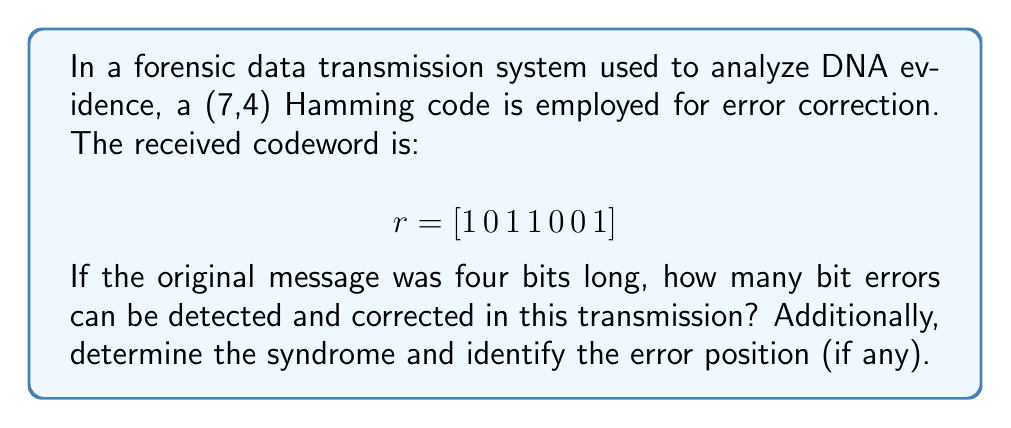Give your solution to this math problem. 1) The (7,4) Hamming code can detect up to 2 errors and correct 1 error.

2) To find the syndrome and error position:
   
   The parity-check matrix H for (7,4) Hamming code is:
   
   $$H = \begin{bmatrix}
   1 & 1 & 1 & 0 & 1 & 0 & 0 \\
   1 & 1 & 0 & 1 & 0 & 1 & 0 \\
   1 & 0 & 1 & 1 & 0 & 0 & 1
   \end{bmatrix}$$

3) Calculate the syndrome $s = Hr^T$:
   
   $$s = \begin{bmatrix}
   1 & 1 & 1 & 0 & 1 & 0 & 0 \\
   1 & 1 & 0 & 1 & 0 & 1 & 0 \\
   1 & 0 & 1 & 1 & 0 & 0 & 1
   \end{bmatrix} \cdot \begin{bmatrix}
   1 \\ 0 \\ 1 \\ 1 \\ 0 \\ 0 \\ 1
   \end{bmatrix} = \begin{bmatrix}
   0 \\ 1 \\ 1
   \end{bmatrix}$$

4) The syndrome $[0\,1\,1]$ corresponds to the binary representation of 3.

5) This indicates an error in the 3rd bit position (counting from left, starting at 1).

6) To correct the error, flip the 3rd bit: $[1\,0\,\mathbf{0}\,1\,0\,0\,1]$

7) The corrected message (first 4 bits) is $[1\,0\,0\,1]$.
Answer: Detect 2, correct 1; Error in 3rd bit; Corrected message: $[1\,0\,0\,1]$ 